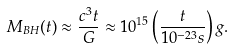Convert formula to latex. <formula><loc_0><loc_0><loc_500><loc_500>M _ { B H } ( t ) \approx \frac { c ^ { 3 } t } { G } \approx 1 0 ^ { 1 5 } \left ( \frac { t } { 1 0 ^ { - 2 3 } s } \right ) g .</formula> 